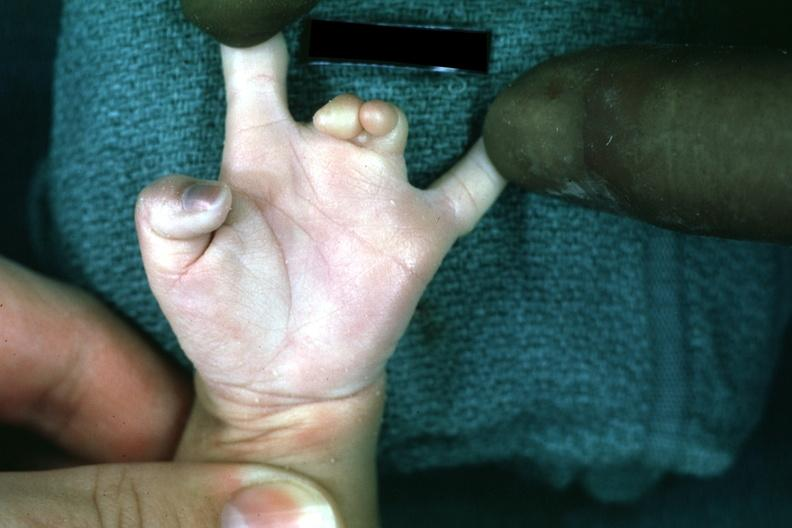s hand present?
Answer the question using a single word or phrase. Yes 